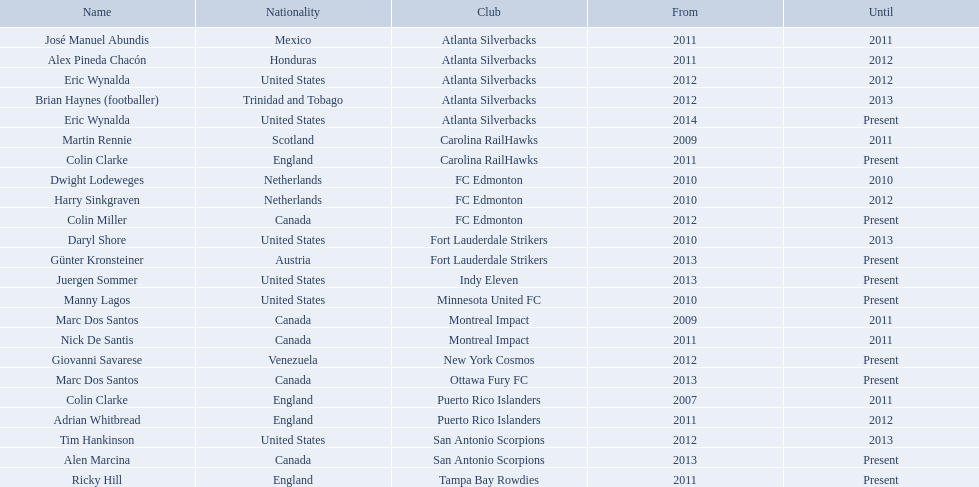What year did marc dos santos start as coach? 2009. Besides marc dos santos, what other coach started in 2009? Martin Rennie. What were all the coaches who were coaching in 2010? Martin Rennie, Dwight Lodeweges, Harry Sinkgraven, Daryl Shore, Manny Lagos, Marc Dos Santos, Colin Clarke. Which of the 2010 coaches were not born in north america? Martin Rennie, Dwight Lodeweges, Harry Sinkgraven, Colin Clarke. Which coaches that were coaching in 2010 and were not from north america did not coach for fc edmonton? Martin Rennie, Colin Clarke. What coach did not coach for fc edmonton in 2010 and was not north american nationality had the shortened career as a coach? Martin Rennie. When did marc dos santos commence his coaching? 2009. What other beginning years coincide with this year? 2009. Which other coach started in the same year? Martin Rennie. In what year did marc dos santos' coaching journey begin? 2009. Are there any other starting years that align with this year? 2009. Who is another coach who began their career in the same year? Martin Rennie. Can you provide a list of all coaches active in 2010? Martin Rennie, Dwight Lodeweges, Harry Sinkgraven, Daryl Shore, Manny Lagos, Marc Dos Santos, Colin Clarke. Which coaches from 2010 were not natives of north america? Martin Rennie, Dwight Lodeweges, Harry Sinkgraven, Colin Clarke. Which 2010 coaches not from north america didn't coach for fc edmonton? Martin Rennie, Colin Clarke. Among these non-north american coaches who didn't coach for fc edmonton in 2010, who had the briefest coaching tenure? Martin Rennie. Who were the coaching staff in the year 2010? Martin Rennie, Dwight Lodeweges, Harry Sinkgraven, Daryl Shore, Manny Lagos, Marc Dos Santos, Colin Clarke. From the 2010 coaches, who were not born in north america? Martin Rennie, Dwight Lodeweges, Harry Sinkgraven, Colin Clarke. Which of the non-north american coaches in 2010 did not serve fc edmonton? Martin Rennie, Colin Clarke. Which coach with non-north american? Martin Rennie. 